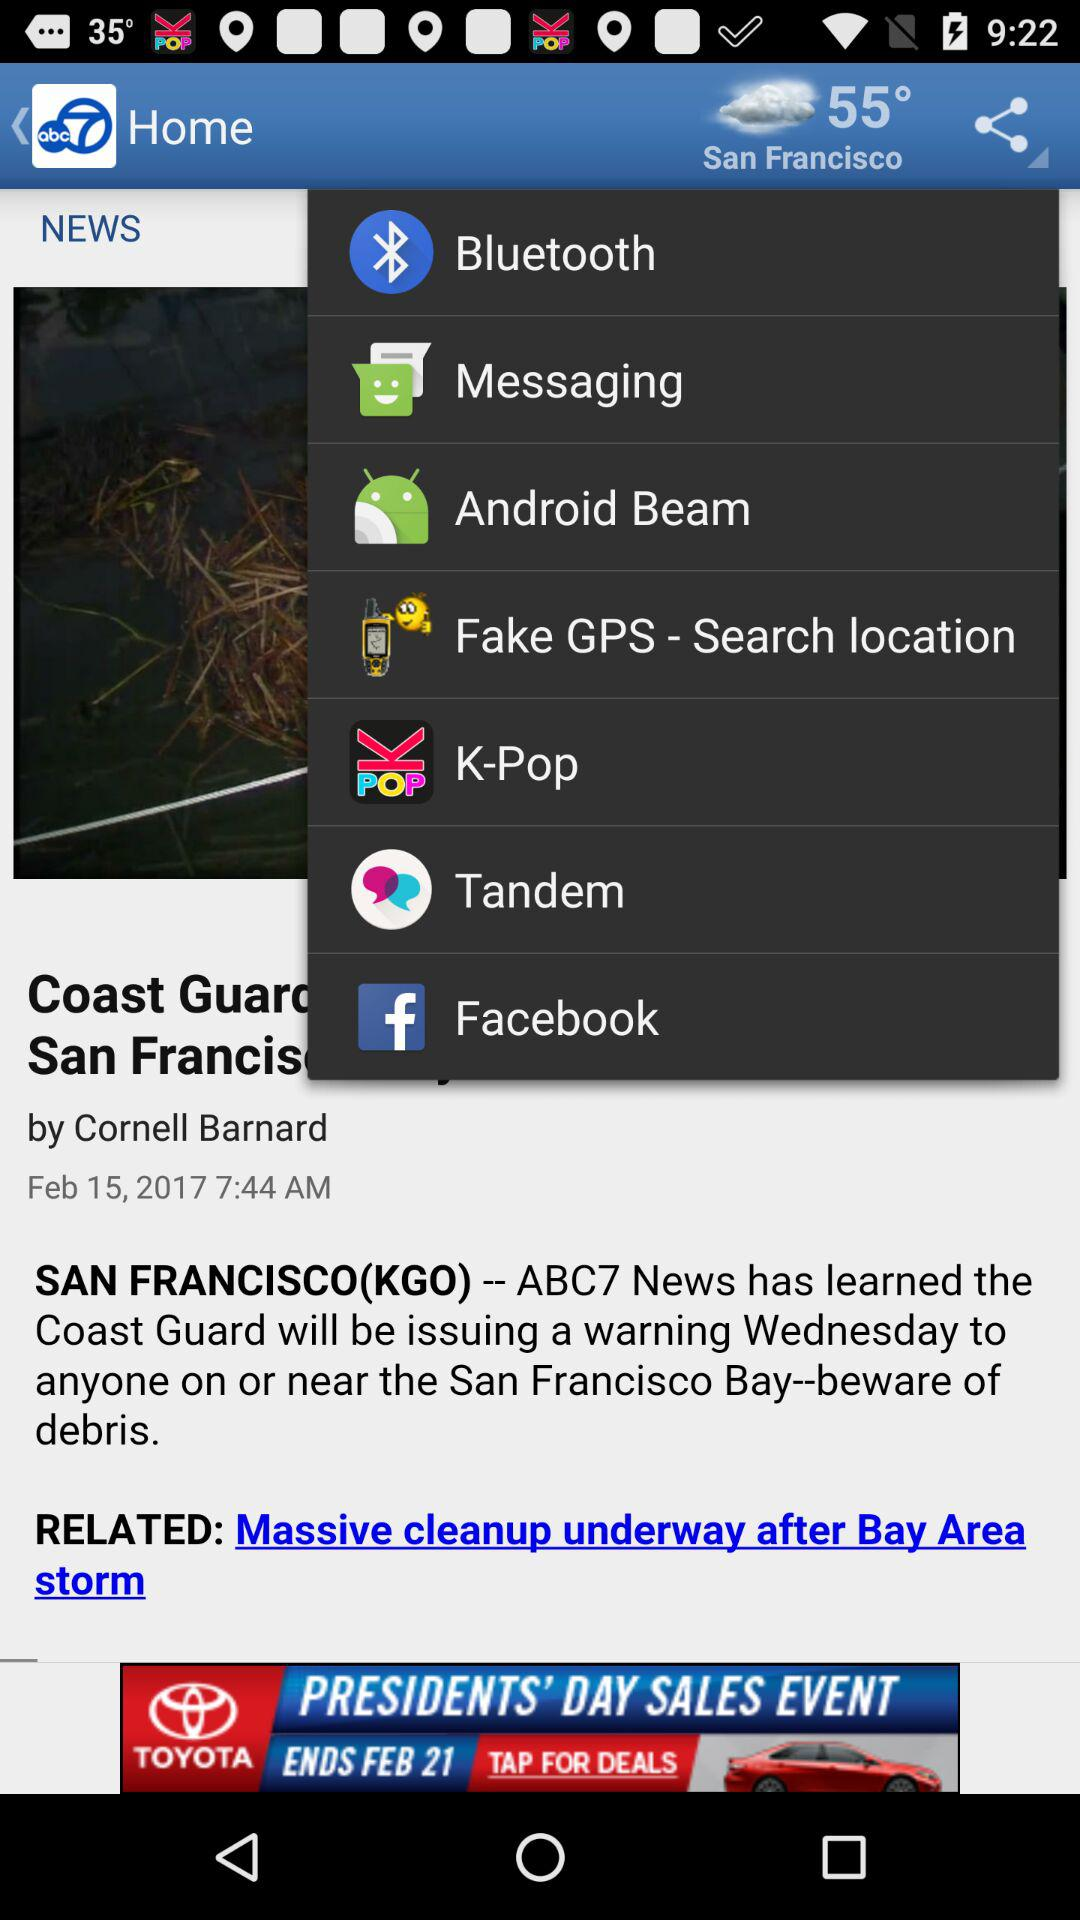Who is the author of the article? The author of the article is Cornell Barnard. 